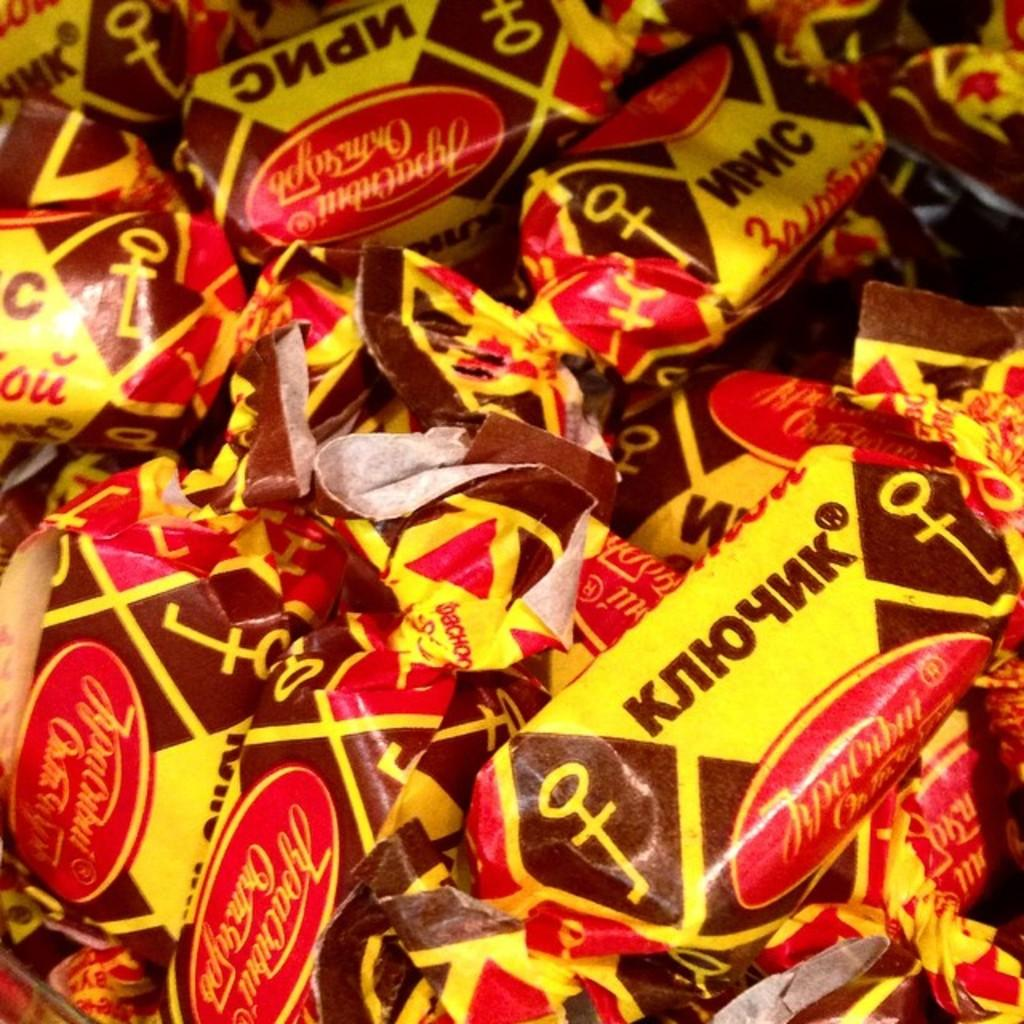What objects are present in the image? There are packs in the image. Can you see any feathers on the packs in the image? There is no mention of feathers in the image, so it cannot be determined if they are present or not. 